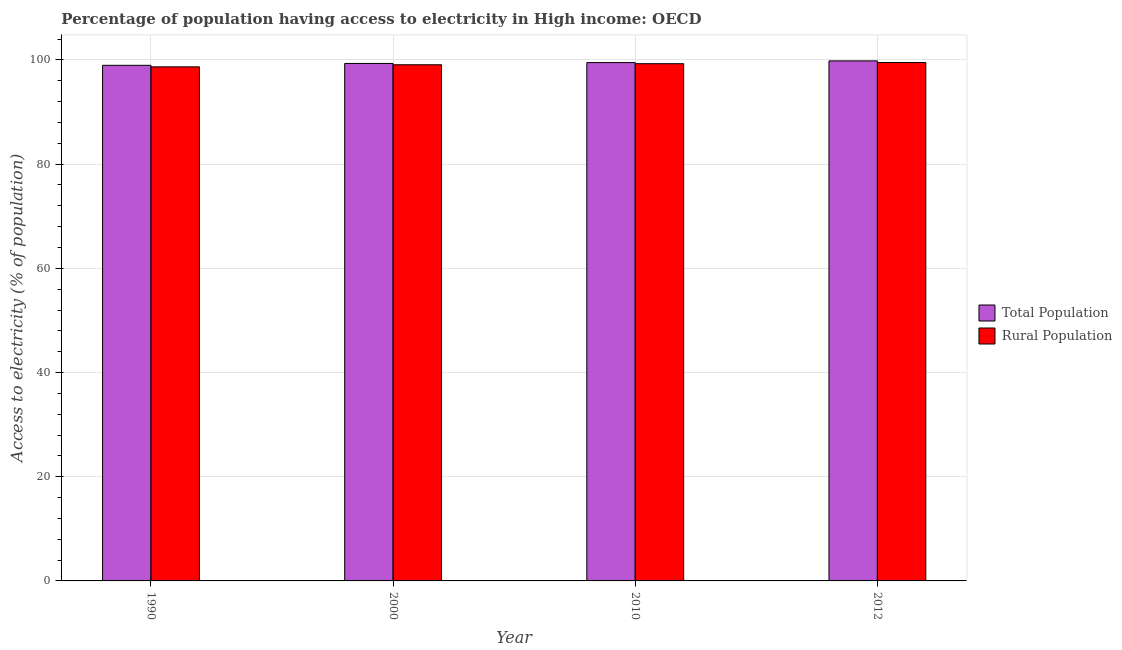How many groups of bars are there?
Ensure brevity in your answer.  4. Are the number of bars per tick equal to the number of legend labels?
Provide a short and direct response. Yes. Are the number of bars on each tick of the X-axis equal?
Offer a very short reply. Yes. How many bars are there on the 2nd tick from the left?
Provide a short and direct response. 2. What is the label of the 2nd group of bars from the left?
Ensure brevity in your answer.  2000. What is the percentage of rural population having access to electricity in 2000?
Provide a short and direct response. 99.08. Across all years, what is the maximum percentage of rural population having access to electricity?
Ensure brevity in your answer.  99.5. Across all years, what is the minimum percentage of population having access to electricity?
Keep it short and to the point. 98.97. In which year was the percentage of rural population having access to electricity maximum?
Keep it short and to the point. 2012. In which year was the percentage of rural population having access to electricity minimum?
Give a very brief answer. 1990. What is the total percentage of population having access to electricity in the graph?
Your answer should be compact. 397.62. What is the difference between the percentage of population having access to electricity in 2010 and that in 2012?
Your answer should be very brief. -0.33. What is the difference between the percentage of rural population having access to electricity in 2000 and the percentage of population having access to electricity in 2012?
Your answer should be compact. -0.43. What is the average percentage of rural population having access to electricity per year?
Provide a succinct answer. 99.13. What is the ratio of the percentage of population having access to electricity in 2000 to that in 2010?
Offer a very short reply. 1. Is the difference between the percentage of rural population having access to electricity in 1990 and 2012 greater than the difference between the percentage of population having access to electricity in 1990 and 2012?
Make the answer very short. No. What is the difference between the highest and the second highest percentage of rural population having access to electricity?
Keep it short and to the point. 0.22. What is the difference between the highest and the lowest percentage of rural population having access to electricity?
Offer a terse response. 0.83. In how many years, is the percentage of population having access to electricity greater than the average percentage of population having access to electricity taken over all years?
Offer a terse response. 2. What does the 2nd bar from the left in 2010 represents?
Offer a terse response. Rural Population. What does the 2nd bar from the right in 2012 represents?
Offer a very short reply. Total Population. Are the values on the major ticks of Y-axis written in scientific E-notation?
Provide a short and direct response. No. Does the graph contain any zero values?
Provide a short and direct response. No. Does the graph contain grids?
Give a very brief answer. Yes. What is the title of the graph?
Give a very brief answer. Percentage of population having access to electricity in High income: OECD. What is the label or title of the Y-axis?
Ensure brevity in your answer.  Access to electricity (% of population). What is the Access to electricity (% of population) of Total Population in 1990?
Your response must be concise. 98.97. What is the Access to electricity (% of population) of Rural Population in 1990?
Give a very brief answer. 98.67. What is the Access to electricity (% of population) in Total Population in 2000?
Give a very brief answer. 99.33. What is the Access to electricity (% of population) of Rural Population in 2000?
Provide a short and direct response. 99.08. What is the Access to electricity (% of population) in Total Population in 2010?
Provide a succinct answer. 99.49. What is the Access to electricity (% of population) in Rural Population in 2010?
Your response must be concise. 99.28. What is the Access to electricity (% of population) in Total Population in 2012?
Give a very brief answer. 99.82. What is the Access to electricity (% of population) of Rural Population in 2012?
Your response must be concise. 99.5. Across all years, what is the maximum Access to electricity (% of population) of Total Population?
Make the answer very short. 99.82. Across all years, what is the maximum Access to electricity (% of population) in Rural Population?
Make the answer very short. 99.5. Across all years, what is the minimum Access to electricity (% of population) of Total Population?
Keep it short and to the point. 98.97. Across all years, what is the minimum Access to electricity (% of population) in Rural Population?
Ensure brevity in your answer.  98.67. What is the total Access to electricity (% of population) of Total Population in the graph?
Your answer should be very brief. 397.62. What is the total Access to electricity (% of population) in Rural Population in the graph?
Provide a short and direct response. 396.54. What is the difference between the Access to electricity (% of population) of Total Population in 1990 and that in 2000?
Provide a short and direct response. -0.36. What is the difference between the Access to electricity (% of population) in Rural Population in 1990 and that in 2000?
Provide a short and direct response. -0.4. What is the difference between the Access to electricity (% of population) of Total Population in 1990 and that in 2010?
Offer a terse response. -0.52. What is the difference between the Access to electricity (% of population) in Rural Population in 1990 and that in 2010?
Your response must be concise. -0.61. What is the difference between the Access to electricity (% of population) in Total Population in 1990 and that in 2012?
Give a very brief answer. -0.85. What is the difference between the Access to electricity (% of population) in Rural Population in 1990 and that in 2012?
Provide a succinct answer. -0.83. What is the difference between the Access to electricity (% of population) of Total Population in 2000 and that in 2010?
Your answer should be compact. -0.16. What is the difference between the Access to electricity (% of population) in Rural Population in 2000 and that in 2010?
Provide a succinct answer. -0.21. What is the difference between the Access to electricity (% of population) in Total Population in 2000 and that in 2012?
Your response must be concise. -0.49. What is the difference between the Access to electricity (% of population) of Rural Population in 2000 and that in 2012?
Keep it short and to the point. -0.43. What is the difference between the Access to electricity (% of population) in Total Population in 2010 and that in 2012?
Offer a terse response. -0.33. What is the difference between the Access to electricity (% of population) in Rural Population in 2010 and that in 2012?
Offer a very short reply. -0.22. What is the difference between the Access to electricity (% of population) in Total Population in 1990 and the Access to electricity (% of population) in Rural Population in 2000?
Keep it short and to the point. -0.1. What is the difference between the Access to electricity (% of population) in Total Population in 1990 and the Access to electricity (% of population) in Rural Population in 2010?
Ensure brevity in your answer.  -0.31. What is the difference between the Access to electricity (% of population) in Total Population in 1990 and the Access to electricity (% of population) in Rural Population in 2012?
Provide a succinct answer. -0.53. What is the difference between the Access to electricity (% of population) of Total Population in 2000 and the Access to electricity (% of population) of Rural Population in 2010?
Your answer should be very brief. 0.05. What is the difference between the Access to electricity (% of population) in Total Population in 2000 and the Access to electricity (% of population) in Rural Population in 2012?
Keep it short and to the point. -0.17. What is the difference between the Access to electricity (% of population) of Total Population in 2010 and the Access to electricity (% of population) of Rural Population in 2012?
Offer a very short reply. -0.01. What is the average Access to electricity (% of population) in Total Population per year?
Keep it short and to the point. 99.4. What is the average Access to electricity (% of population) of Rural Population per year?
Make the answer very short. 99.13. In the year 1990, what is the difference between the Access to electricity (% of population) in Total Population and Access to electricity (% of population) in Rural Population?
Keep it short and to the point. 0.3. In the year 2000, what is the difference between the Access to electricity (% of population) of Total Population and Access to electricity (% of population) of Rural Population?
Give a very brief answer. 0.25. In the year 2010, what is the difference between the Access to electricity (% of population) in Total Population and Access to electricity (% of population) in Rural Population?
Offer a terse response. 0.21. In the year 2012, what is the difference between the Access to electricity (% of population) in Total Population and Access to electricity (% of population) in Rural Population?
Give a very brief answer. 0.32. What is the ratio of the Access to electricity (% of population) of Rural Population in 1990 to that in 2000?
Keep it short and to the point. 1. What is the ratio of the Access to electricity (% of population) of Total Population in 1990 to that in 2012?
Your answer should be very brief. 0.99. What is the ratio of the Access to electricity (% of population) in Rural Population in 1990 to that in 2012?
Ensure brevity in your answer.  0.99. What is the ratio of the Access to electricity (% of population) in Total Population in 2000 to that in 2012?
Ensure brevity in your answer.  1. What is the ratio of the Access to electricity (% of population) of Rural Population in 2000 to that in 2012?
Keep it short and to the point. 1. What is the difference between the highest and the second highest Access to electricity (% of population) in Total Population?
Your answer should be very brief. 0.33. What is the difference between the highest and the second highest Access to electricity (% of population) in Rural Population?
Give a very brief answer. 0.22. What is the difference between the highest and the lowest Access to electricity (% of population) of Total Population?
Keep it short and to the point. 0.85. What is the difference between the highest and the lowest Access to electricity (% of population) of Rural Population?
Offer a terse response. 0.83. 